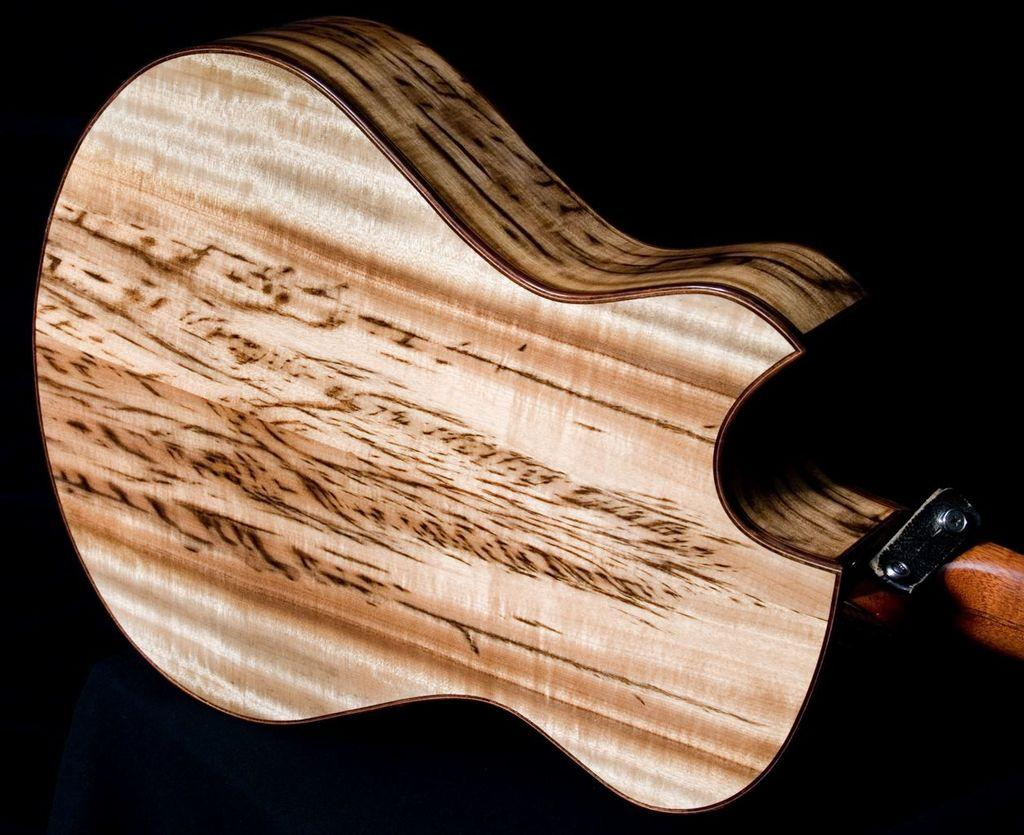What musical instrument is present in the image? There is a guitar in the image. Can you describe the guitar in more detail? The provided facts do not give any additional details about the guitar. What might someone be doing with the guitar in the image? The image does not show any specific action being performed with the guitar, so it is not possible to determine what someone might be doing with it. What type of sign can be seen in the wilderness area of the image? There is no sign or wilderness area present in the image; it only features a guitar. 